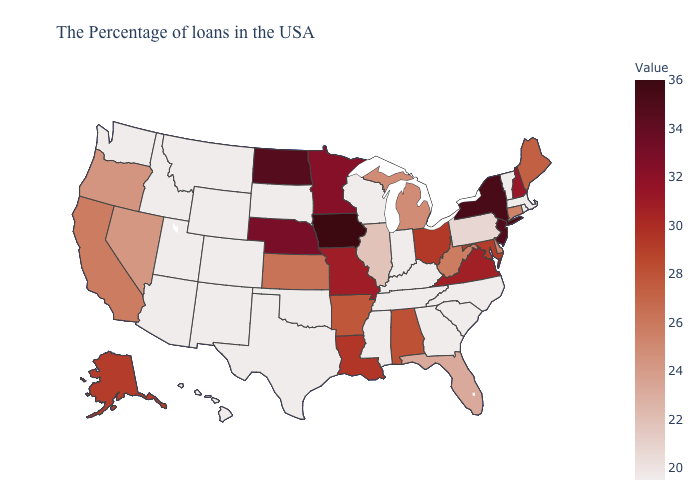Which states have the lowest value in the South?
Answer briefly. North Carolina, South Carolina, Georgia, Kentucky, Tennessee, Mississippi, Oklahoma, Texas. Among the states that border North Carolina , which have the highest value?
Write a very short answer. Virginia. Which states have the lowest value in the USA?
Concise answer only. Massachusetts, Rhode Island, Vermont, North Carolina, South Carolina, Georgia, Kentucky, Indiana, Tennessee, Wisconsin, Mississippi, Oklahoma, Texas, South Dakota, Wyoming, Colorado, New Mexico, Utah, Montana, Arizona, Idaho, Washington, Hawaii. Does Kentucky have a higher value than Virginia?
Give a very brief answer. No. Which states have the lowest value in the USA?
Keep it brief. Massachusetts, Rhode Island, Vermont, North Carolina, South Carolina, Georgia, Kentucky, Indiana, Tennessee, Wisconsin, Mississippi, Oklahoma, Texas, South Dakota, Wyoming, Colorado, New Mexico, Utah, Montana, Arizona, Idaho, Washington, Hawaii. 